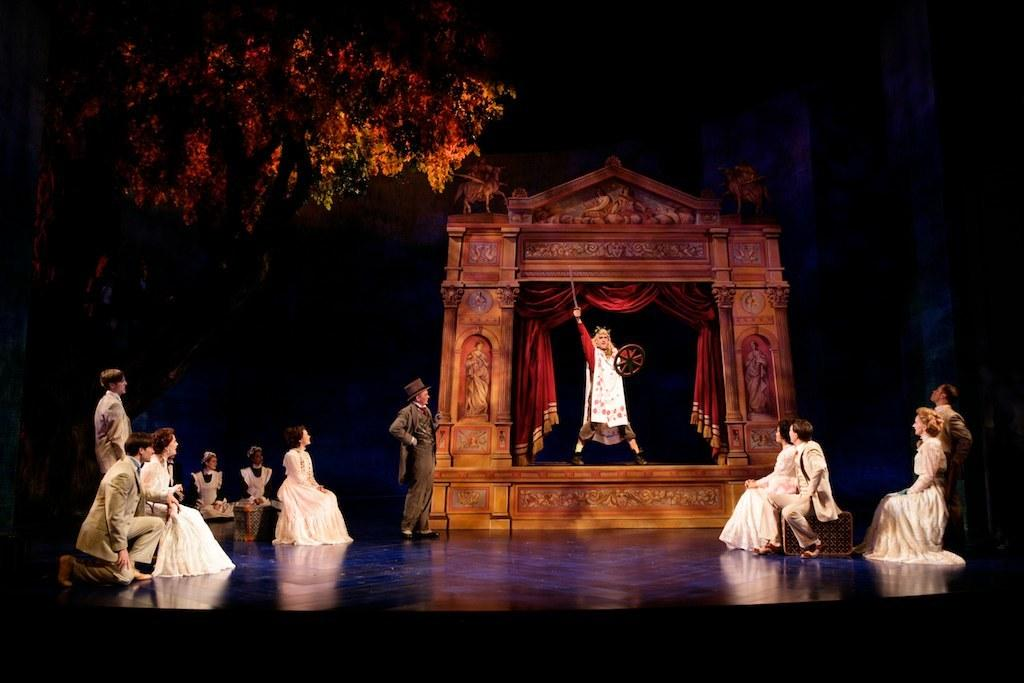How many people are in the image? There is a group of people in the image, but the exact number is not specified. What are the people in the image doing? Some people are sitting, while others are standing. What can be seen in the background of the image? There is an arch and trees in the background of the image. What type of nut is being used as a ball by the team in the image? There is no team or nut present in the image. How many oranges are visible on the trees in the image? There are no oranges visible on the trees in the image. 